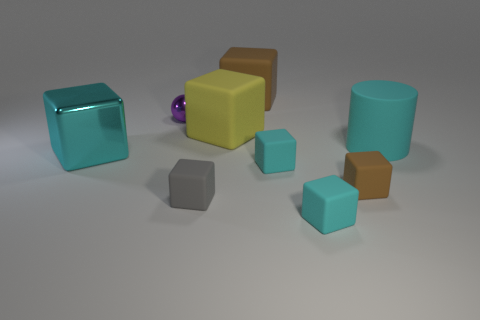Add 1 small purple metallic balls. How many objects exist? 10 Subtract all gray cubes. How many cubes are left? 6 Subtract all spheres. How many objects are left? 8 Subtract all cyan matte cubes. How many cubes are left? 5 Subtract 1 cylinders. How many cylinders are left? 0 Subtract 0 purple blocks. How many objects are left? 9 Subtract all yellow cubes. Subtract all red cylinders. How many cubes are left? 6 Subtract all blue cylinders. How many yellow blocks are left? 1 Subtract all small cyan matte blocks. Subtract all cyan matte blocks. How many objects are left? 5 Add 2 gray things. How many gray things are left? 3 